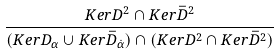<formula> <loc_0><loc_0><loc_500><loc_500>\frac { K e r D ^ { 2 } \cap K e r \bar { D } ^ { 2 } } { ( K e r D _ { \alpha } \cup K e r \bar { D } _ { \dot { \alpha } } ) \cap ( K e r D ^ { 2 } \cap K e r \bar { D } ^ { 2 } ) }</formula> 